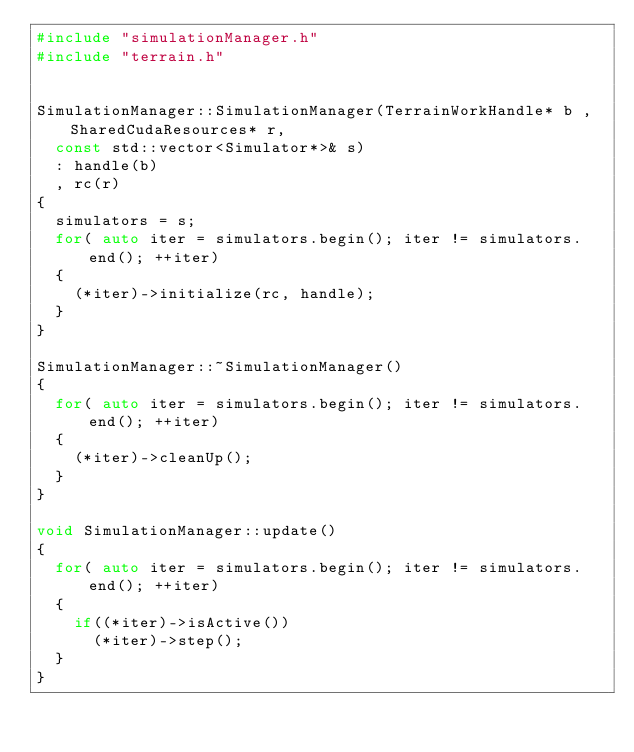<code> <loc_0><loc_0><loc_500><loc_500><_C++_>#include "simulationManager.h"
#include "terrain.h"


SimulationManager::SimulationManager(TerrainWorkHandle* b , SharedCudaResources* r,
	const std::vector<Simulator*>& s)
	: handle(b)
	, rc(r)
{
	simulators = s;
	for( auto iter = simulators.begin(); iter != simulators.end(); ++iter)
	{
		(*iter)->initialize(rc, handle);
	}
}

SimulationManager::~SimulationManager()
{
	for( auto iter = simulators.begin(); iter != simulators.end(); ++iter)
	{
		(*iter)->cleanUp();
	}
}

void SimulationManager::update()
{
	for( auto iter = simulators.begin(); iter != simulators.end(); ++iter)
	{
		if((*iter)->isActive())
			(*iter)->step();
	}
}</code> 